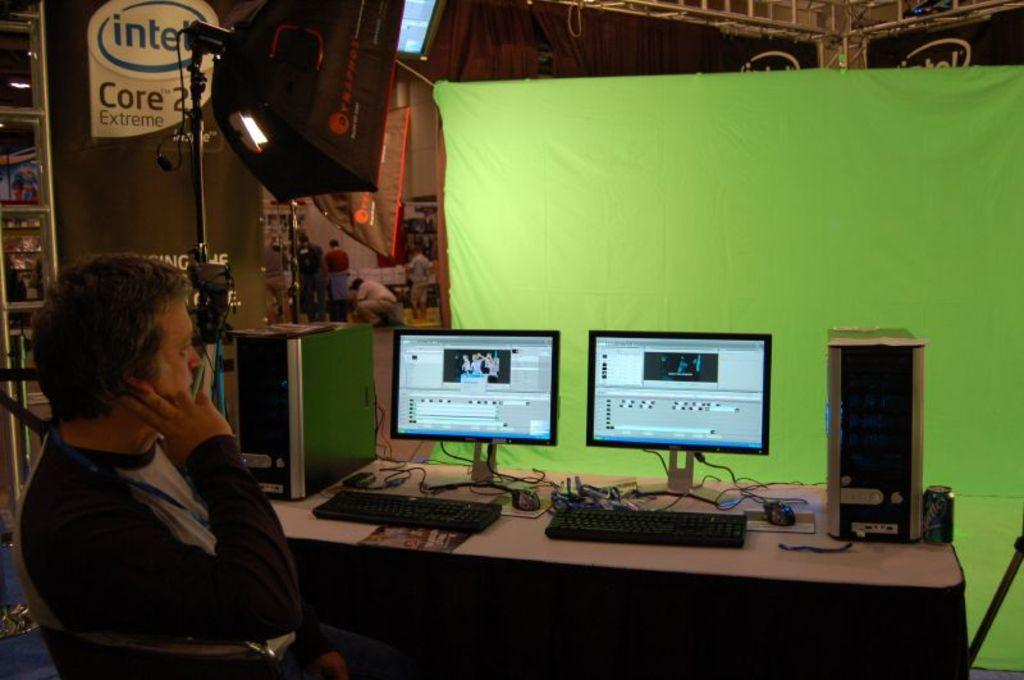<image>
Give a short and clear explanation of the subsequent image. Person in front of two monitors and a sign on the side which says Intel. 